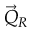<formula> <loc_0><loc_0><loc_500><loc_500>\vec { Q } _ { R }</formula> 